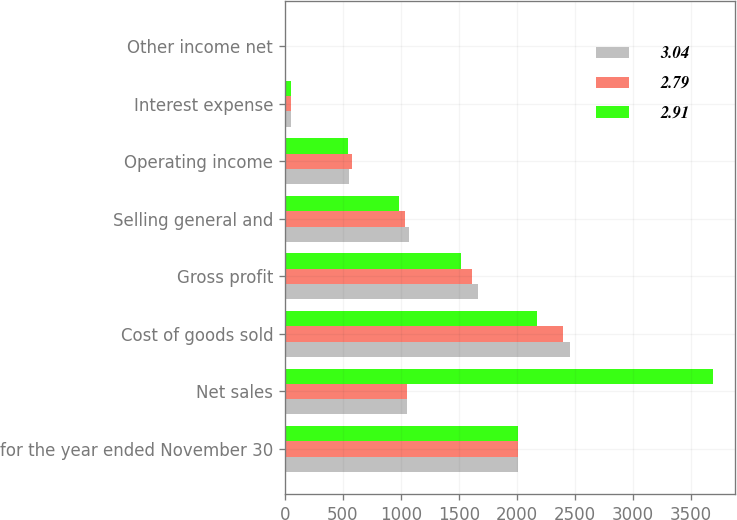Convert chart to OTSL. <chart><loc_0><loc_0><loc_500><loc_500><stacked_bar_chart><ecel><fcel>for the year ended November 30<fcel>Net sales<fcel>Cost of goods sold<fcel>Gross profit<fcel>Selling general and<fcel>Operating income<fcel>Interest expense<fcel>Other income net<nl><fcel>3.04<fcel>2013<fcel>1057.25<fcel>2457.6<fcel>1665.8<fcel>1075<fcel>550.5<fcel>53.3<fcel>2.2<nl><fcel>2.79<fcel>2012<fcel>1057.25<fcel>2396.4<fcel>1617.8<fcel>1039.5<fcel>578.3<fcel>54.6<fcel>2.4<nl><fcel>2.91<fcel>2011<fcel>3697.6<fcel>2175.1<fcel>1522.5<fcel>982.2<fcel>540.3<fcel>51.2<fcel>2.3<nl></chart> 